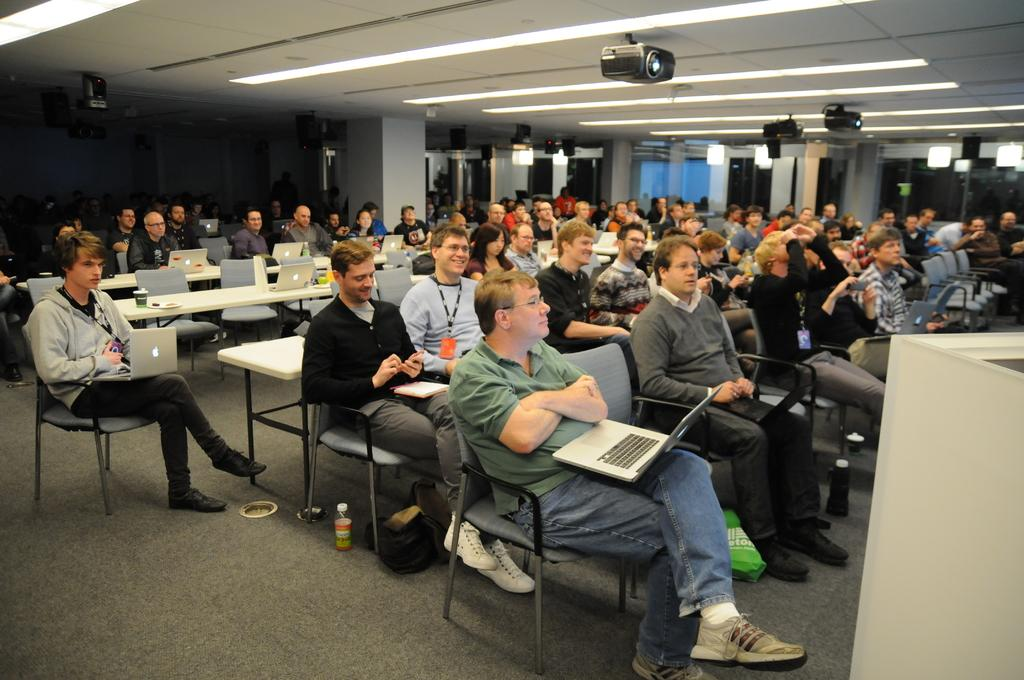How many people are in the image? There are many people in the image. What are the people doing in the image? The people are sitting on chairs and holding laptops. Can you describe the projector in the image? The projector is attached to the ceiling. What type of silk is being used to create the smoke in the image? There is no silk or smoke present in the image. How hot is the room where the people are sitting in the image? The provided facts do not give any information about the temperature of the room, so we cannot determine how hot it is. 